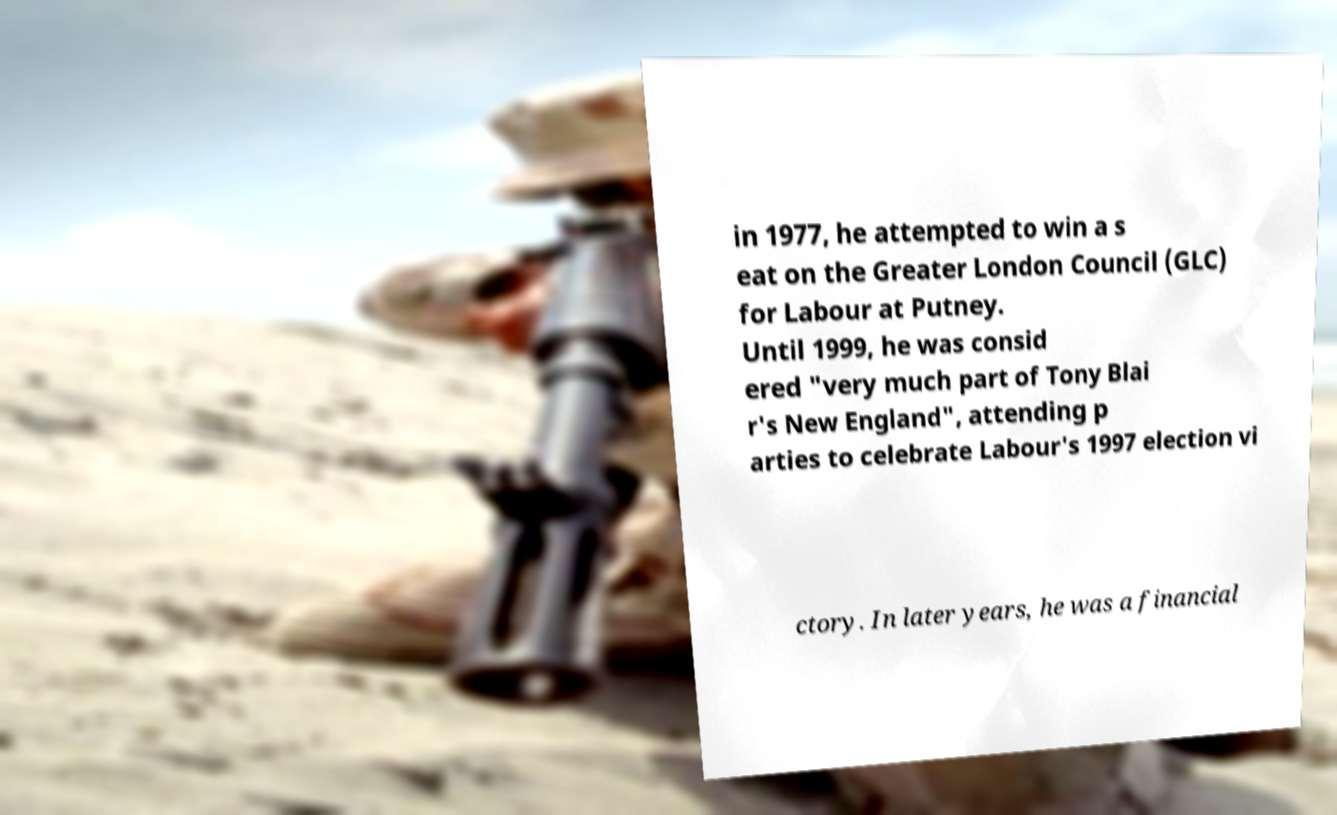For documentation purposes, I need the text within this image transcribed. Could you provide that? in 1977, he attempted to win a s eat on the Greater London Council (GLC) for Labour at Putney. Until 1999, he was consid ered "very much part of Tony Blai r's New England", attending p arties to celebrate Labour's 1997 election vi ctory. In later years, he was a financial 